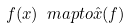Convert formula to latex. <formula><loc_0><loc_0><loc_500><loc_500>f ( x ) \ m a p t o \hat { x } ( f )</formula> 